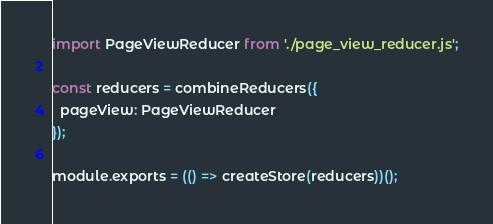<code> <loc_0><loc_0><loc_500><loc_500><_JavaScript_>import PageViewReducer from './page_view_reducer.js';

const reducers = combineReducers({
  pageView: PageViewReducer
});

module.exports = (() => createStore(reducers))();</code> 